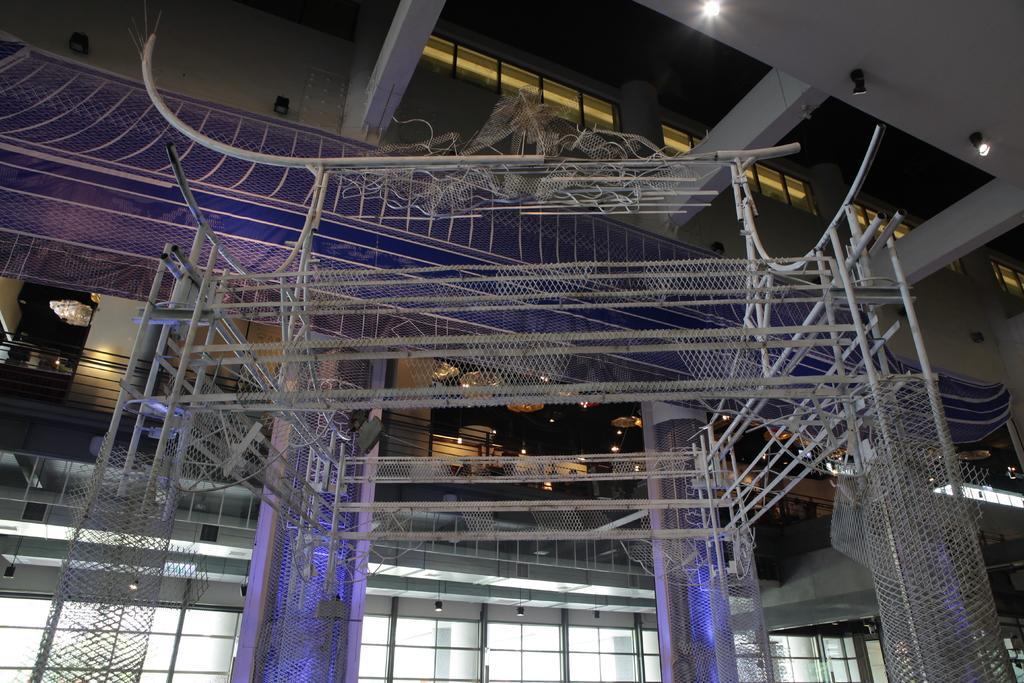Could you give a brief overview of what you see in this image? This image consists of a building. In the front, we can see metal rods along with net. In the background, there is a balcony. At the top, there is a roof along with the lights. And we can see the beams. 